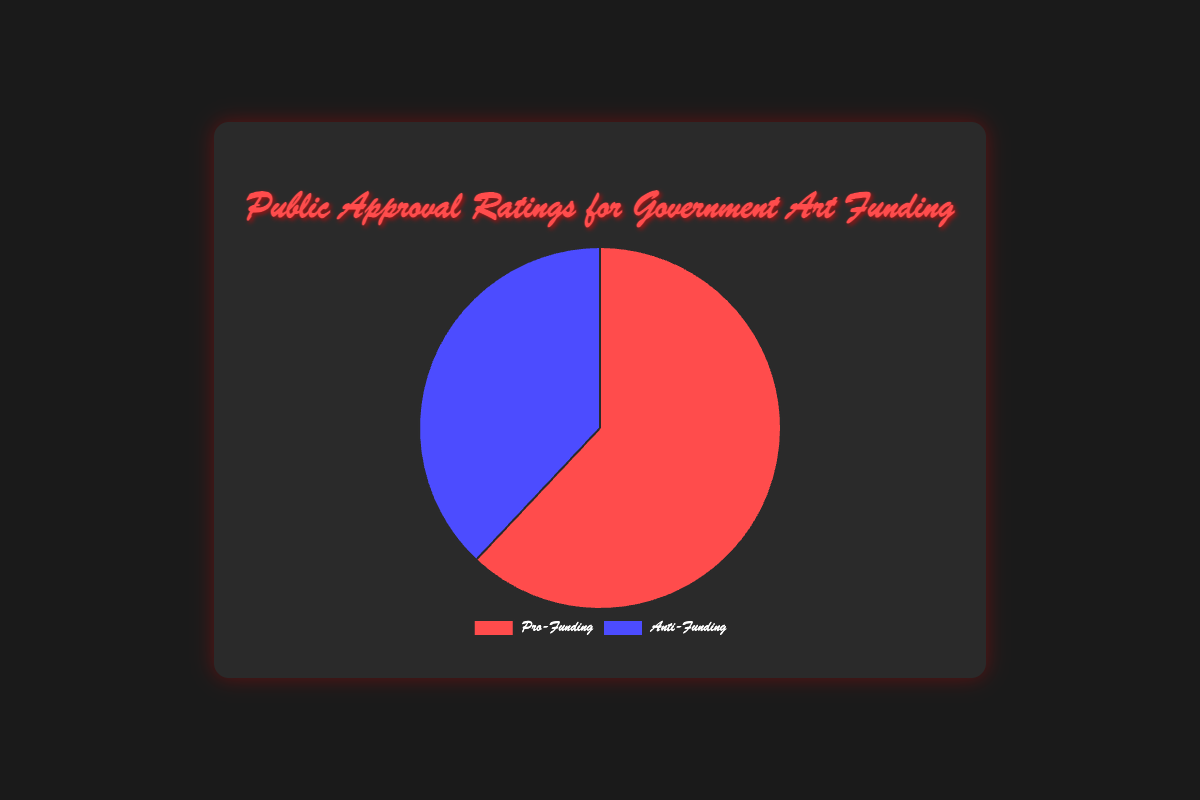What percentage of the public supports government art funding? The pie chart shows two data points: Pro-Funding at 62% and Anti-Funding at 38%. Since the question asks about support, we focus on the Pro-Funding segment.
Answer: 62% What is the difference between the percentage of people who support and those who oppose government art funding? The Pro-Funding segment is at 62% and the Anti-Funding segment is at 38%. The difference is calculated by subtracting the smaller percentage from the larger one: 62% - 38% = 24%.
Answer: 24% Which category has a higher approval rating, Pro-Funding or Anti-Funding? The pie chart shows that Pro-Funding has a higher approval rating at 62% while Anti-Funding is at 38%.
Answer: Pro-Funding What percentage of the rural population supports government art funding? Referring to the details of the Pro-Funding segment, the percentage of the rural population that supports government art funding is 50%.
Answer: 50% Compare the support for government art funding among urban and rural populations. In the Pro-Funding segment, support among the urban population is 70% while it is 50% among the rural population. Urban support is higher than rural support (70% > 50%).
Answer: Urban support is higher What is the sum of the percentages of the 18-34 and 55+ age groups in the Pro-Funding category? From the demographics data of the Pro-Funding segment, the percentage for ages 18-34 is 68% and for 55+ is 56%. Sum = 68% + 56% = 124%.
Answer: 124% How does support for government art funding among 18-34-year-olds compare to those aged 55+? For the Pro-Funding segment, 68% of the 18-34 age group supports funding, while 56% of the 55+ group does. The younger age group has higher support (68% > 56%).
Answer: Higher support among 18-34 Visually, which segment of the pie chart is represented by a red color? The visual attributes of the pie chart indicate that the Pro-Funding segment is represented by the red color.
Answer: Pro-Funding What is the average support for government art funding across urban, suburban, and rural populations? For the Pro-Funding segment, the support percentages are 70% (urban), 64% (suburban), and 50% (rural). The average is calculated as (70% + 64% + 50%) / 3 = 61.33%.
Answer: 61.33% If the total survey sample size is considered, how many people are in favor of government art funding? The sample size for the Pro-Funding poll is 1500. Since 62% support funding, the number of people in favor = 62% of 1500 = 0.62 * 1500 = 930 people.
Answer: 930 people 